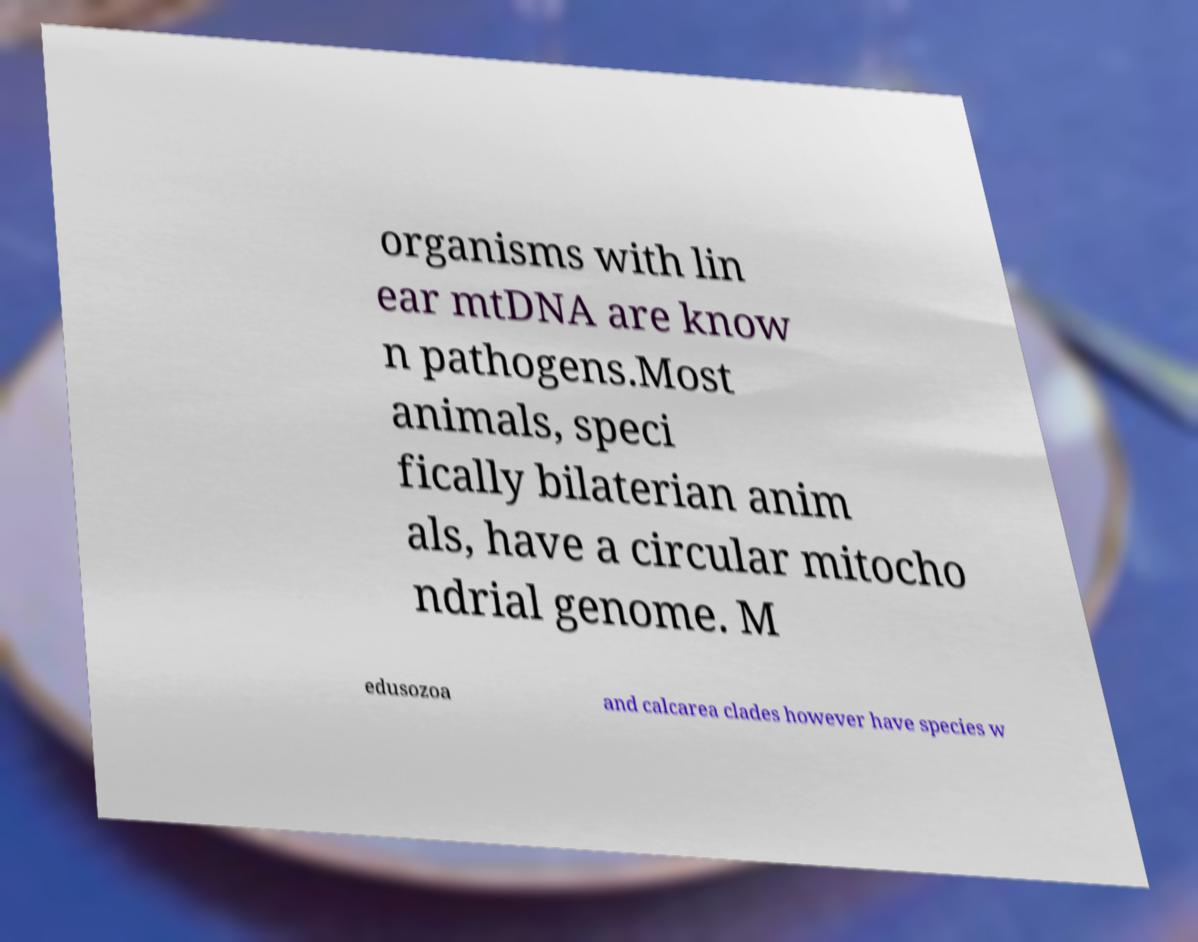For documentation purposes, I need the text within this image transcribed. Could you provide that? organisms with lin ear mtDNA are know n pathogens.Most animals, speci fically bilaterian anim als, have a circular mitocho ndrial genome. M edusozoa and calcarea clades however have species w 